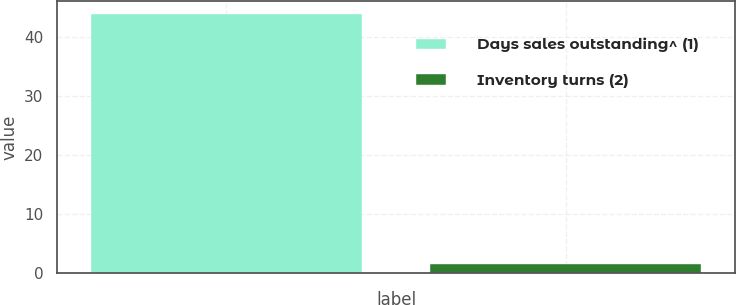Convert chart. <chart><loc_0><loc_0><loc_500><loc_500><bar_chart><fcel>Days sales outstanding^ (1)<fcel>Inventory turns (2)<nl><fcel>43.8<fcel>1.5<nl></chart> 